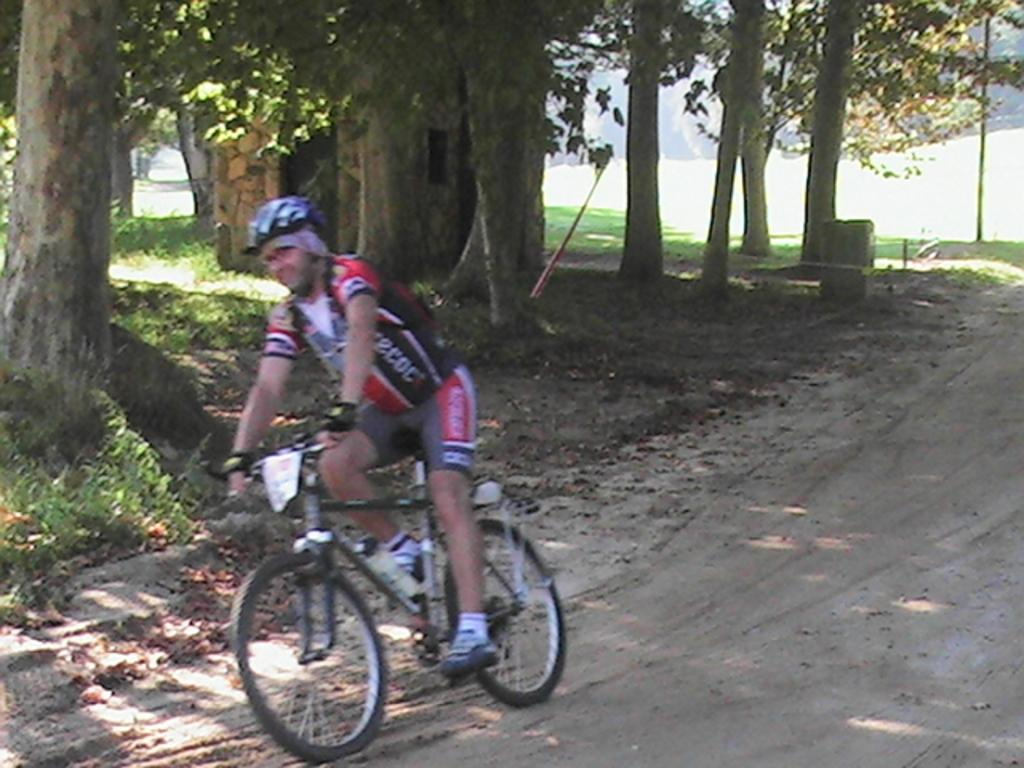What is the person in the image doing? There is a person riding a bicycle in the image. What type of structure can be seen in the image? There is a small house in the image. What type of vegetation is present in the image? There is grass, plants, and trees in the image. Where is the harbor located in the image? There is no harbor present in the image. What type of bed is visible in the image? There is no bed present in the image. 